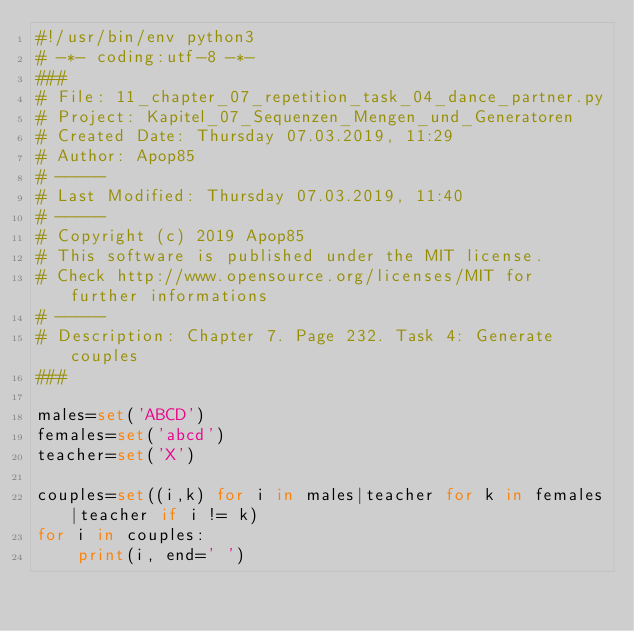Convert code to text. <code><loc_0><loc_0><loc_500><loc_500><_Python_>#!/usr/bin/env python3
# -*- coding:utf-8 -*-
###
# File: 11_chapter_07_repetition_task_04_dance_partner.py
# Project: Kapitel_07_Sequenzen_Mengen_und_Generatoren
# Created Date: Thursday 07.03.2019, 11:29
# Author: Apop85
# -----
# Last Modified: Thursday 07.03.2019, 11:40
# -----
# Copyright (c) 2019 Apop85
# This software is published under the MIT license.
# Check http://www.opensource.org/licenses/MIT for further informations
# -----
# Description: Chapter 7. Page 232. Task 4: Generate couples 
###

males=set('ABCD')
females=set('abcd')
teacher=set('X')

couples=set((i,k) for i in males|teacher for k in females|teacher if i != k)
for i in couples:
    print(i, end=' ')
</code> 